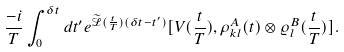<formula> <loc_0><loc_0><loc_500><loc_500>\frac { - i } { T } \int _ { 0 } ^ { \delta t } d t ^ { \prime } e ^ { \widetilde { \mathcal { L } } ( \frac { t } { T } ) ( \delta t - t ^ { \prime } ) } [ V ( \frac { t } { T } ) , \rho _ { k l } ^ { A } ( t ) \otimes \varrho ^ { B } _ { l } ( \frac { t } { T } ) ] .</formula> 